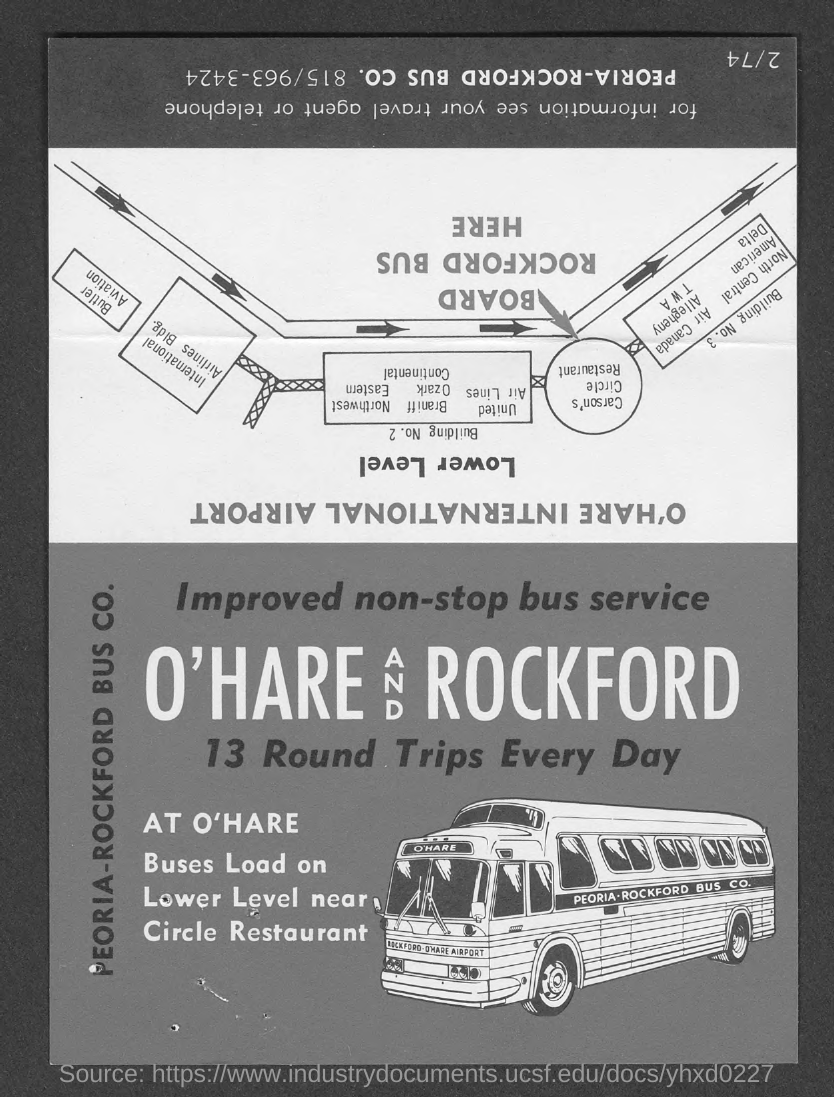Point out several critical features in this image. On a daily basis, there is a total of 13 round trips. 